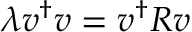<formula> <loc_0><loc_0><loc_500><loc_500>\lambda v ^ { \dagger } v = v ^ { \dagger } R v</formula> 